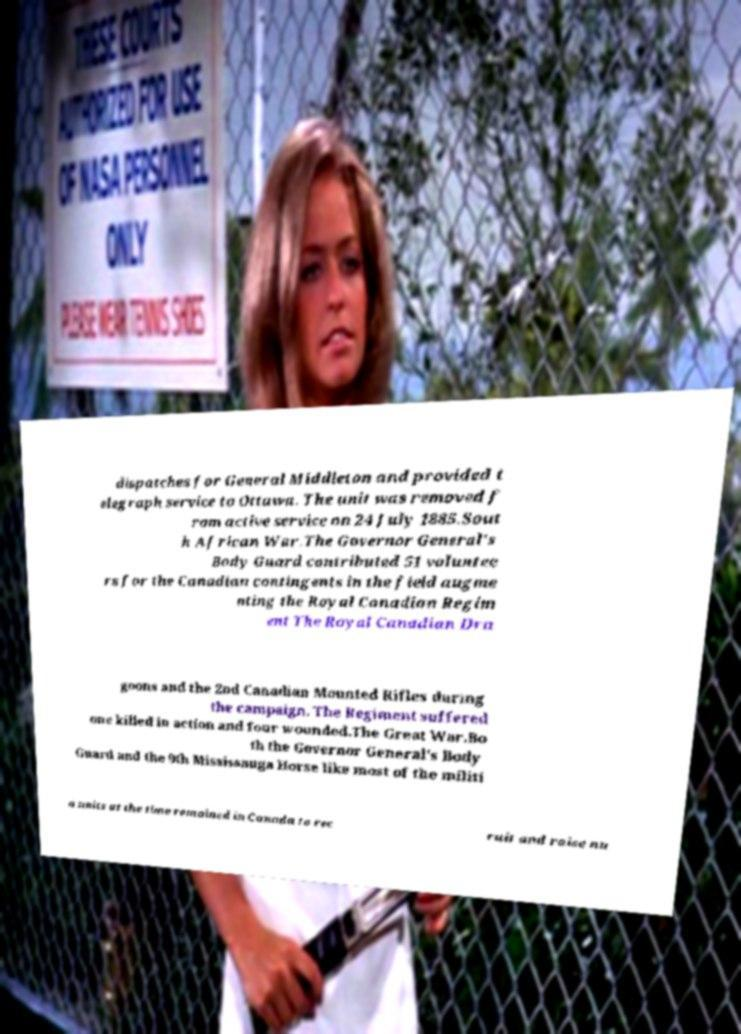Can you accurately transcribe the text from the provided image for me? dispatches for General Middleton and provided t elegraph service to Ottawa. The unit was removed f rom active service on 24 July 1885.Sout h African War.The Governor General's Body Guard contributed 51 voluntee rs for the Canadian contingents in the field augme nting the Royal Canadian Regim ent The Royal Canadian Dra goons and the 2nd Canadian Mounted Rifles during the campaign. The Regiment suffered one killed in action and four wounded.The Great War.Bo th the Governor General's Body Guard and the 9th Mississauga Horse like most of the militi a units at the time remained in Canada to rec ruit and raise nu 